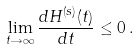<formula> <loc_0><loc_0><loc_500><loc_500>\lim _ { t \rightarrow \infty } \frac { d H ^ { ( s ) } ( t ) } { d t } \leq 0 \, .</formula> 